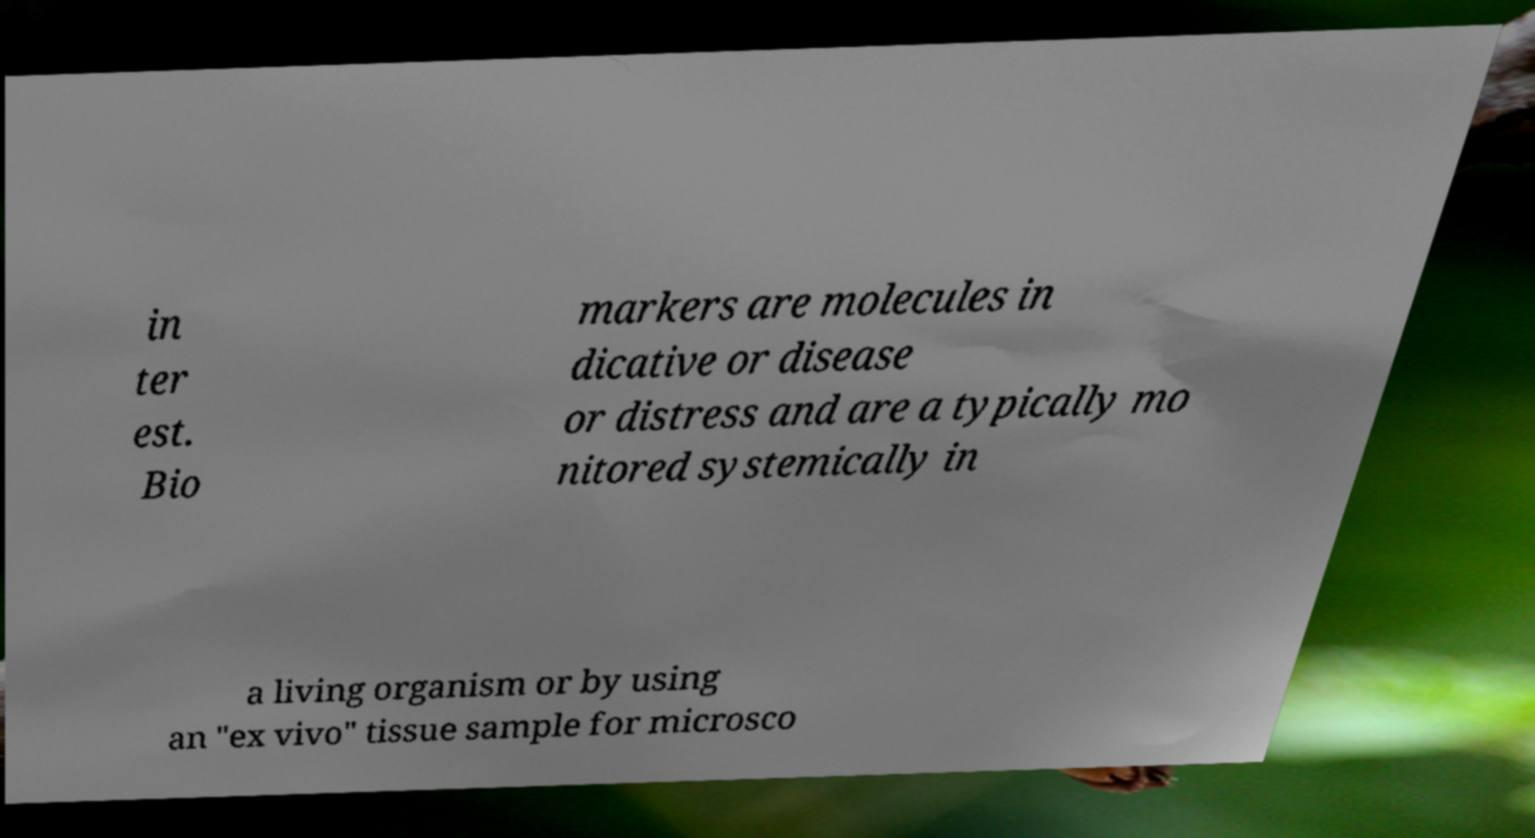Please identify and transcribe the text found in this image. in ter est. Bio markers are molecules in dicative or disease or distress and are a typically mo nitored systemically in a living organism or by using an "ex vivo" tissue sample for microsco 